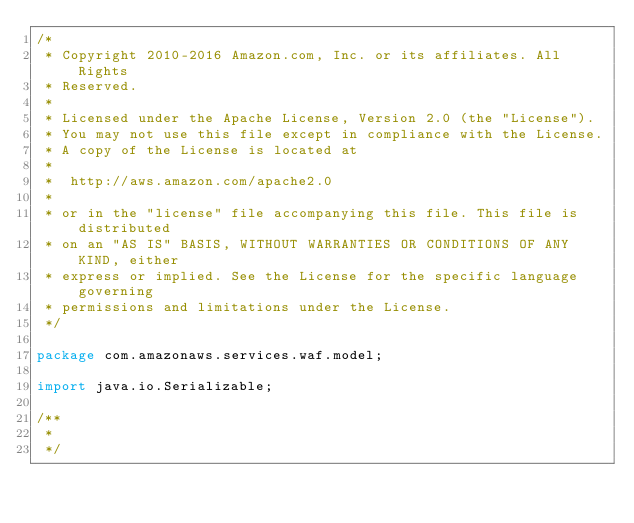<code> <loc_0><loc_0><loc_500><loc_500><_Java_>/*
 * Copyright 2010-2016 Amazon.com, Inc. or its affiliates. All Rights
 * Reserved.
 *
 * Licensed under the Apache License, Version 2.0 (the "License").
 * You may not use this file except in compliance with the License.
 * A copy of the License is located at
 *
 *  http://aws.amazon.com/apache2.0
 *
 * or in the "license" file accompanying this file. This file is distributed
 * on an "AS IS" BASIS, WITHOUT WARRANTIES OR CONDITIONS OF ANY KIND, either
 * express or implied. See the License for the specific language governing
 * permissions and limitations under the License.
 */

package com.amazonaws.services.waf.model;

import java.io.Serializable;

/**
 * 
 */</code> 